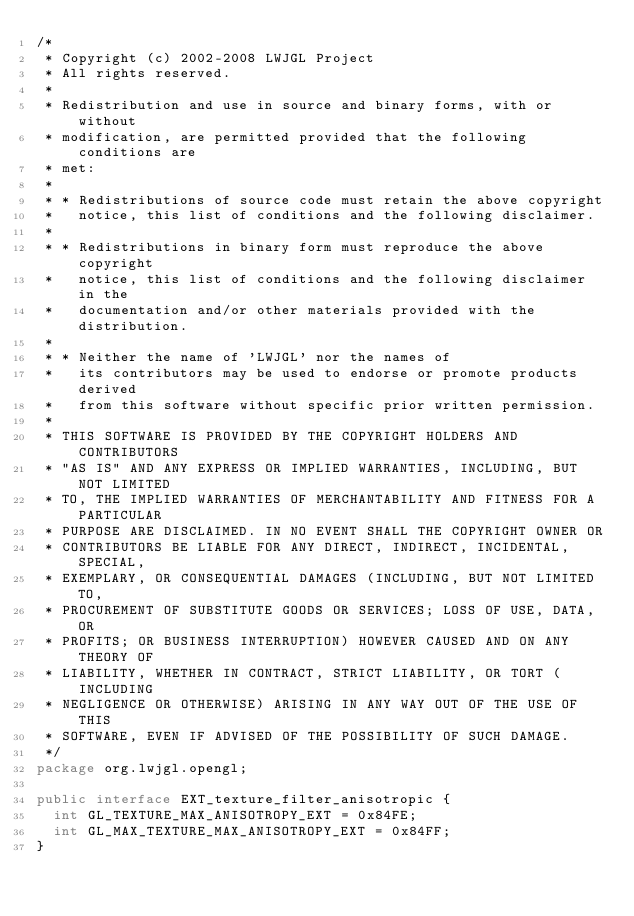<code> <loc_0><loc_0><loc_500><loc_500><_Java_>/*
 * Copyright (c) 2002-2008 LWJGL Project
 * All rights reserved.
 *
 * Redistribution and use in source and binary forms, with or without
 * modification, are permitted provided that the following conditions are
 * met:
 *
 * * Redistributions of source code must retain the above copyright
 *   notice, this list of conditions and the following disclaimer.
 *
 * * Redistributions in binary form must reproduce the above copyright
 *   notice, this list of conditions and the following disclaimer in the
 *   documentation and/or other materials provided with the distribution.
 *
 * * Neither the name of 'LWJGL' nor the names of
 *   its contributors may be used to endorse or promote products derived
 *   from this software without specific prior written permission.
 *
 * THIS SOFTWARE IS PROVIDED BY THE COPYRIGHT HOLDERS AND CONTRIBUTORS
 * "AS IS" AND ANY EXPRESS OR IMPLIED WARRANTIES, INCLUDING, BUT NOT LIMITED
 * TO, THE IMPLIED WARRANTIES OF MERCHANTABILITY AND FITNESS FOR A PARTICULAR
 * PURPOSE ARE DISCLAIMED. IN NO EVENT SHALL THE COPYRIGHT OWNER OR
 * CONTRIBUTORS BE LIABLE FOR ANY DIRECT, INDIRECT, INCIDENTAL, SPECIAL,
 * EXEMPLARY, OR CONSEQUENTIAL DAMAGES (INCLUDING, BUT NOT LIMITED TO,
 * PROCUREMENT OF SUBSTITUTE GOODS OR SERVICES; LOSS OF USE, DATA, OR
 * PROFITS; OR BUSINESS INTERRUPTION) HOWEVER CAUSED AND ON ANY THEORY OF
 * LIABILITY, WHETHER IN CONTRACT, STRICT LIABILITY, OR TORT (INCLUDING
 * NEGLIGENCE OR OTHERWISE) ARISING IN ANY WAY OUT OF THE USE OF THIS
 * SOFTWARE, EVEN IF ADVISED OF THE POSSIBILITY OF SUCH DAMAGE.
 */
package org.lwjgl.opengl;

public interface EXT_texture_filter_anisotropic {
	int GL_TEXTURE_MAX_ANISOTROPY_EXT = 0x84FE;
	int GL_MAX_TEXTURE_MAX_ANISOTROPY_EXT = 0x84FF;
}
</code> 